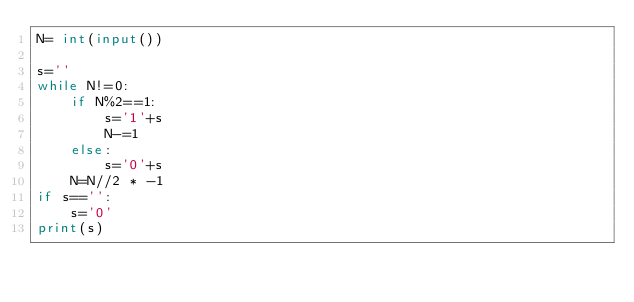<code> <loc_0><loc_0><loc_500><loc_500><_Python_>N= int(input())

s=''
while N!=0:
    if N%2==1:
        s='1'+s
        N-=1
    else:
        s='0'+s
    N=N//2 * -1
if s=='':
    s='0'
print(s)
</code> 